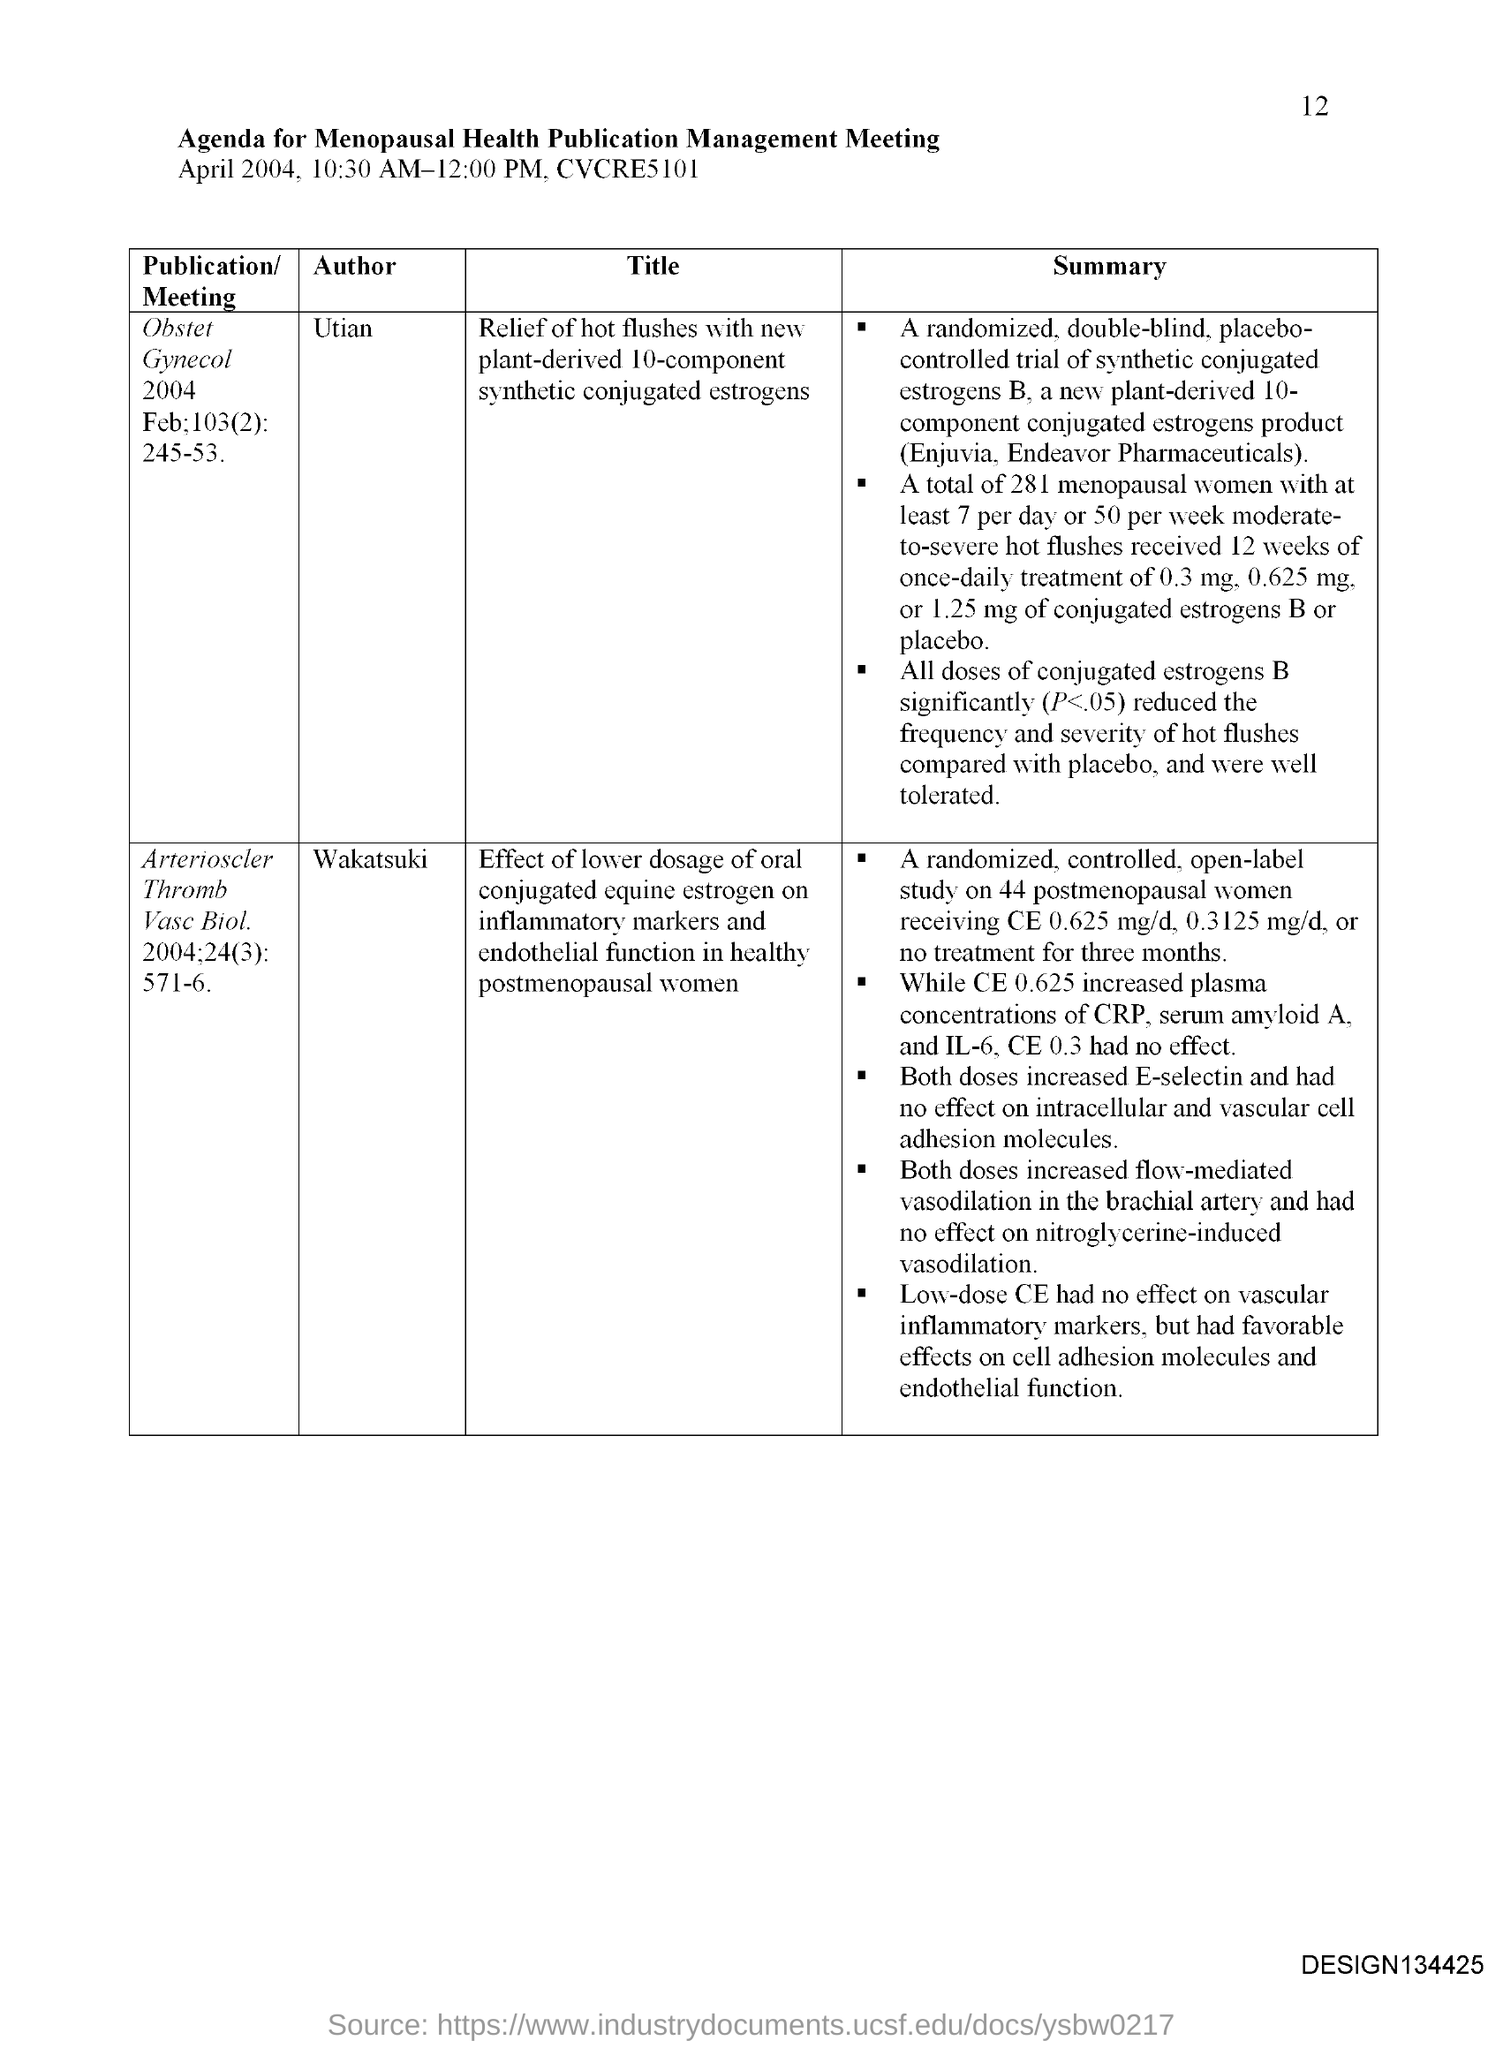When is the Menopausal Health Publication Management Meeting held?
Your answer should be compact. April 2004, 10:30 AM-12:00 PM. What is the page no mentioned in this document?
Make the answer very short. 12. 